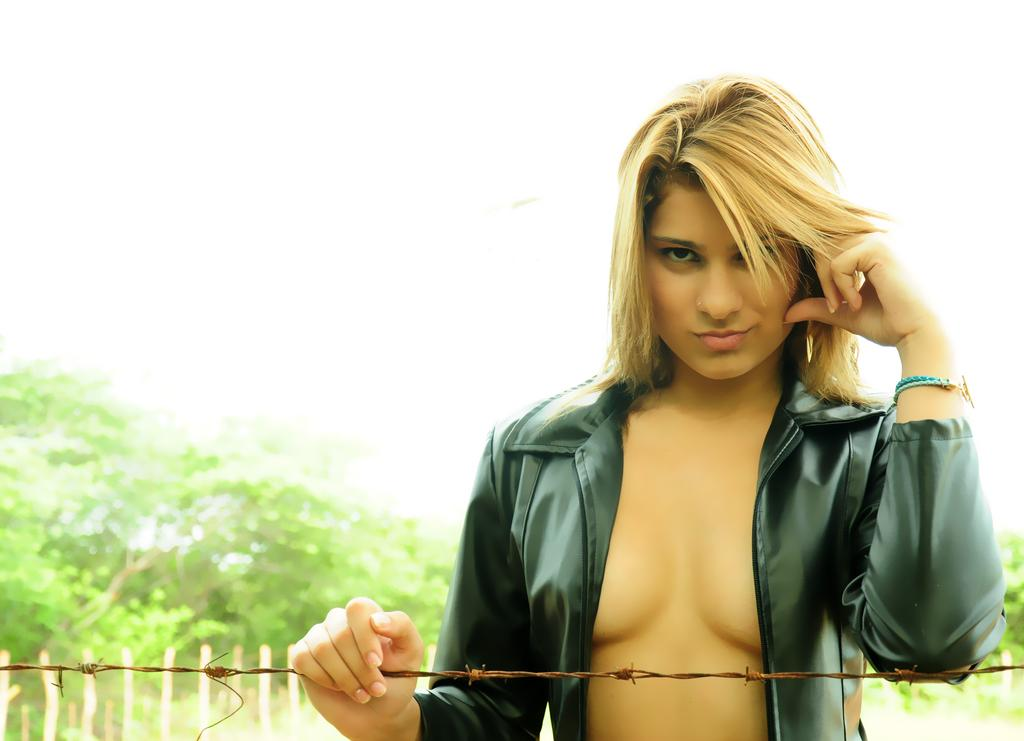What is the main subject of the image? There is a woman standing in the image. What is in front of the woman? There is a wire in front of the woman. What is behind the woman? There are wooden sticks and trees behind the woman. What can be seen in the background of the image? The sky is visible in the background of the image. What type of pocket can be seen in the aftermath of the society depicted in the image? There is no pocket, aftermath, or society depicted in the image; it features a woman standing with a wire in front of her and wooden sticks and trees behind her. 